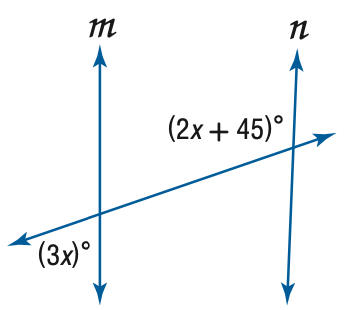Answer the mathemtical geometry problem and directly provide the correct option letter.
Question: Find x so that m \parallel n.
Choices: A: 9 B: 27 C: 45 D: 81 B 